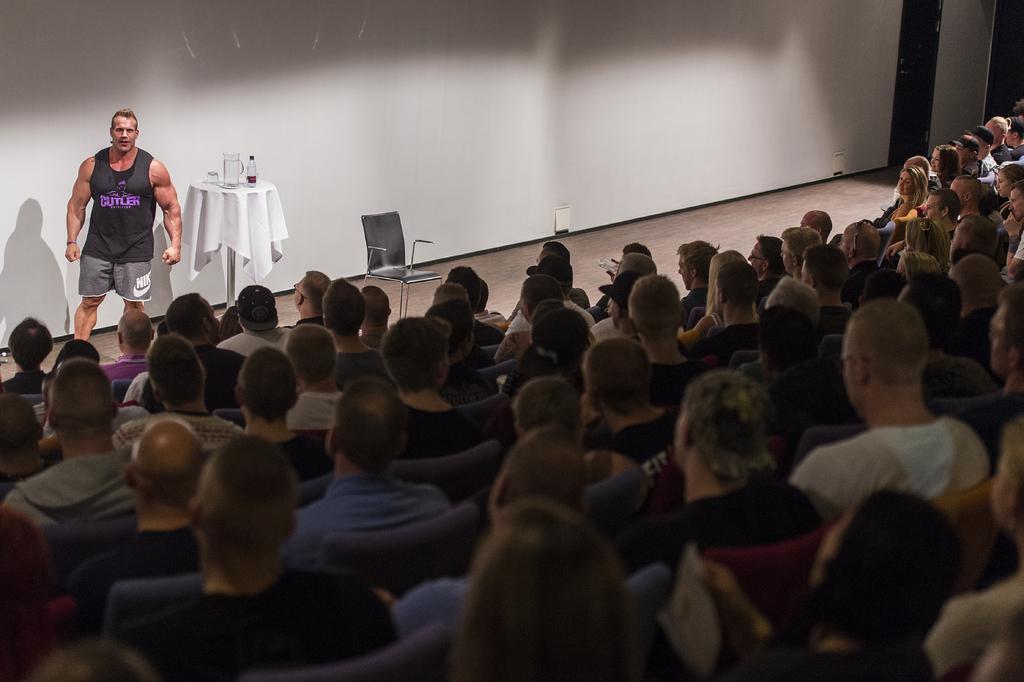Describe this image in one or two sentences. In this image there is a person wearing a black top is standing on the stage having a table and a chair on it. Table is covered with a cloth. On the table there is a jar, bottle and a glass are on it. There are few persons are sitting on the chair. Background there is wall. 